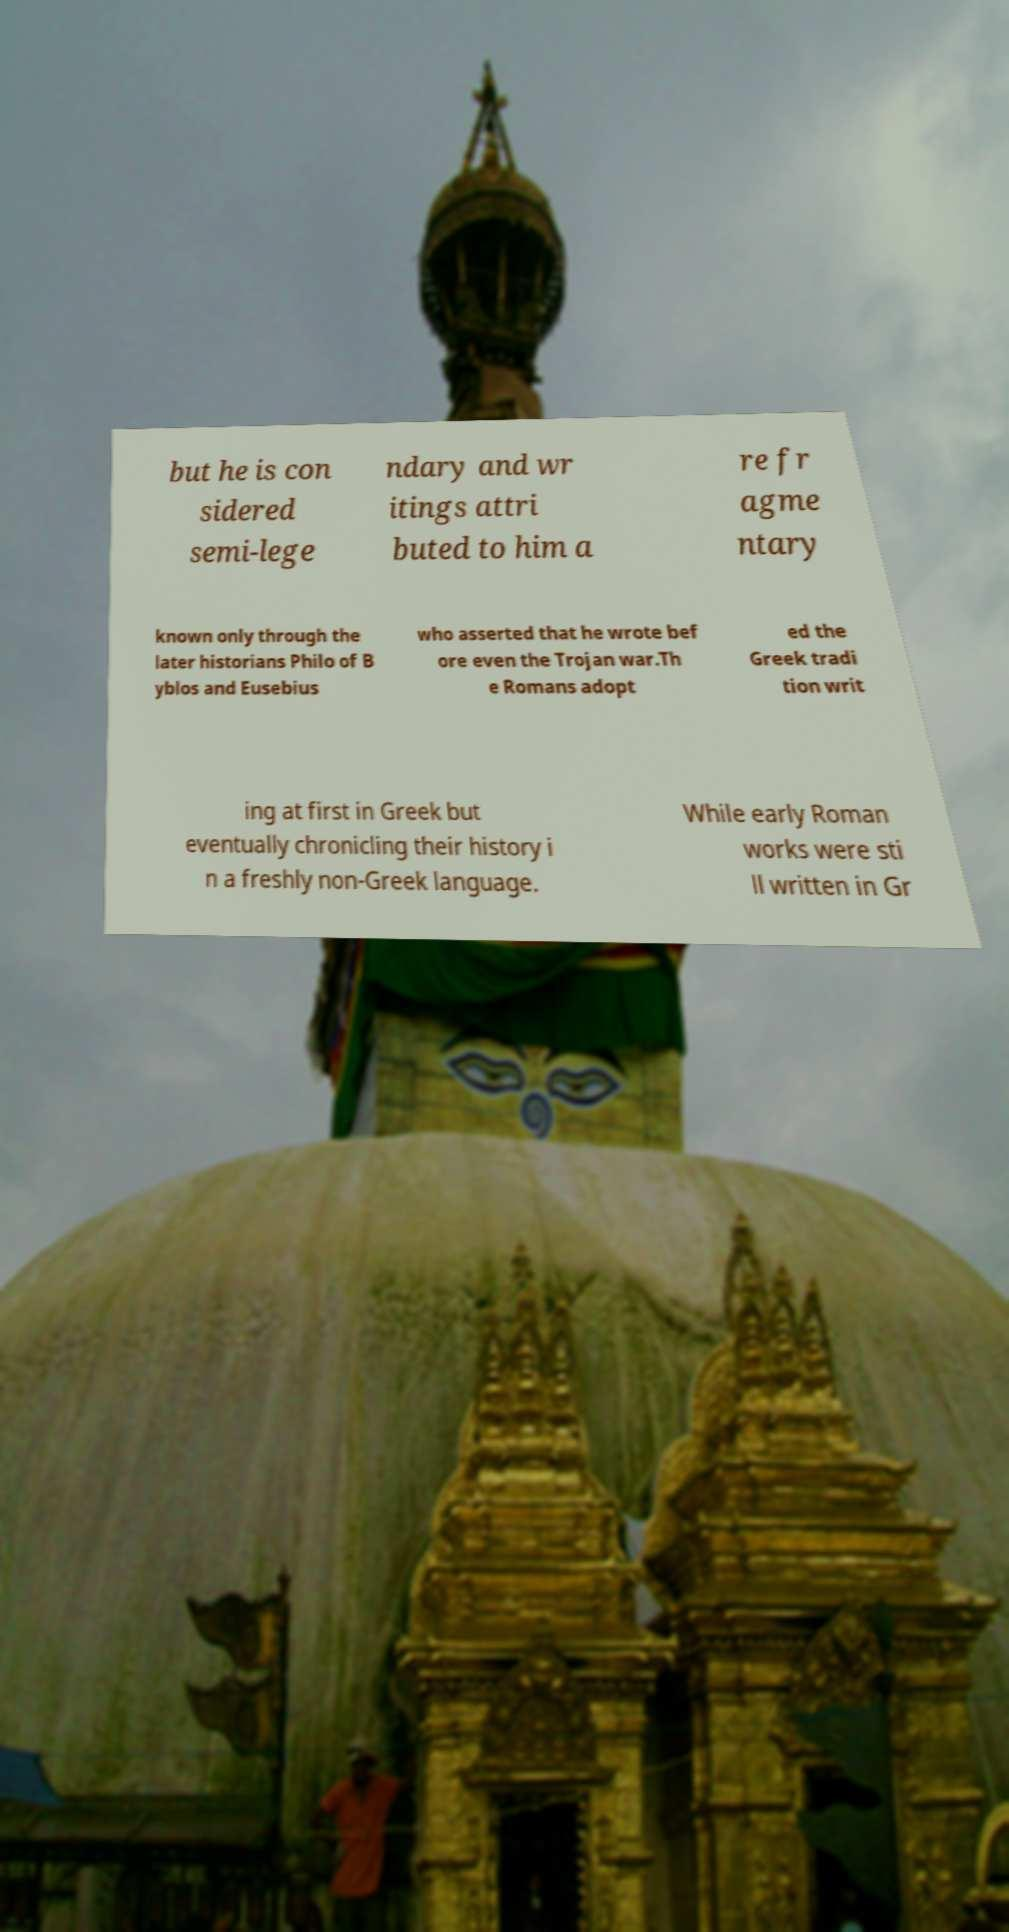Could you extract and type out the text from this image? but he is con sidered semi-lege ndary and wr itings attri buted to him a re fr agme ntary known only through the later historians Philo of B yblos and Eusebius who asserted that he wrote bef ore even the Trojan war.Th e Romans adopt ed the Greek tradi tion writ ing at first in Greek but eventually chronicling their history i n a freshly non-Greek language. While early Roman works were sti ll written in Gr 